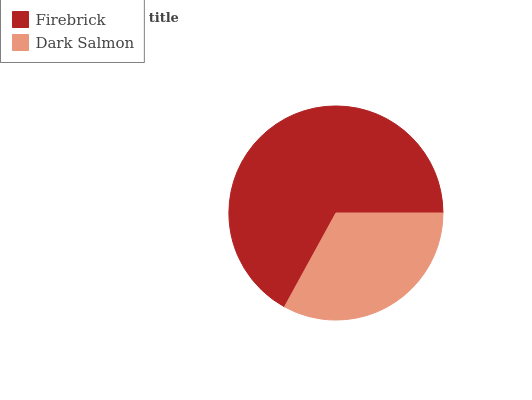Is Dark Salmon the minimum?
Answer yes or no. Yes. Is Firebrick the maximum?
Answer yes or no. Yes. Is Dark Salmon the maximum?
Answer yes or no. No. Is Firebrick greater than Dark Salmon?
Answer yes or no. Yes. Is Dark Salmon less than Firebrick?
Answer yes or no. Yes. Is Dark Salmon greater than Firebrick?
Answer yes or no. No. Is Firebrick less than Dark Salmon?
Answer yes or no. No. Is Firebrick the high median?
Answer yes or no. Yes. Is Dark Salmon the low median?
Answer yes or no. Yes. Is Dark Salmon the high median?
Answer yes or no. No. Is Firebrick the low median?
Answer yes or no. No. 